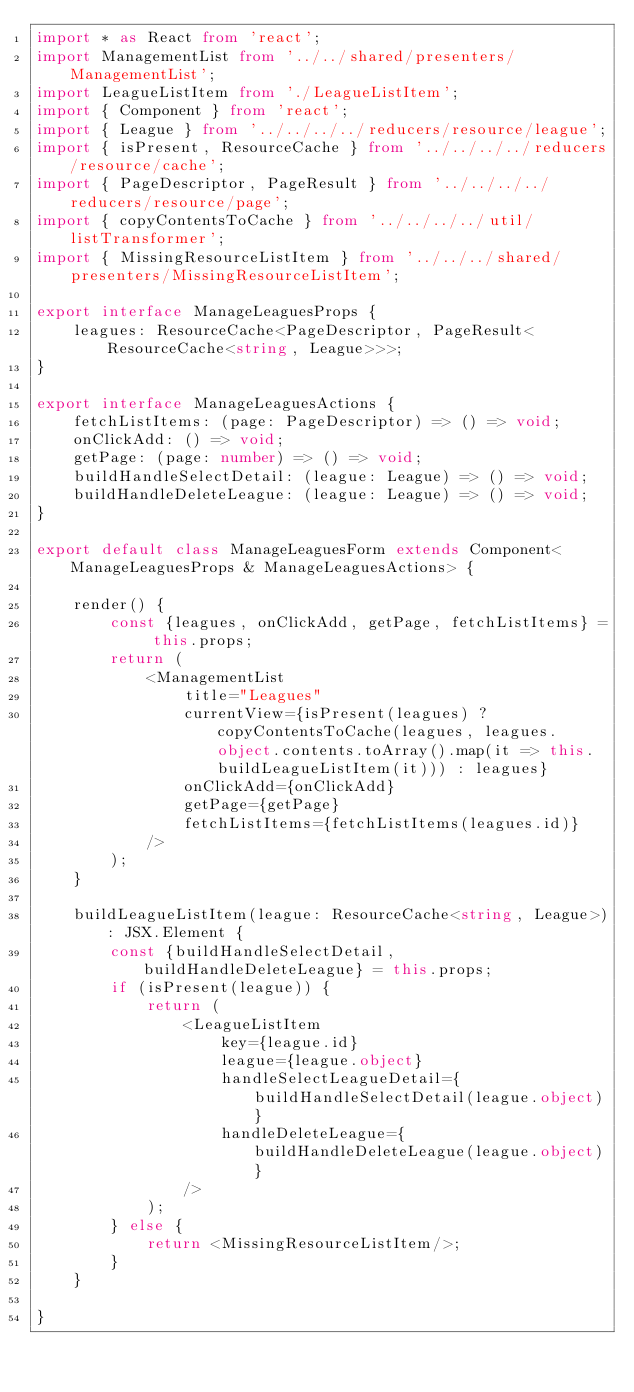Convert code to text. <code><loc_0><loc_0><loc_500><loc_500><_TypeScript_>import * as React from 'react';
import ManagementList from '../../shared/presenters/ManagementList';
import LeagueListItem from './LeagueListItem';
import { Component } from 'react';
import { League } from '../../../../reducers/resource/league';
import { isPresent, ResourceCache } from '../../../../reducers/resource/cache';
import { PageDescriptor, PageResult } from '../../../../reducers/resource/page';
import { copyContentsToCache } from '../../../../util/listTransformer';
import { MissingResourceListItem } from '../../../shared/presenters/MissingResourceListItem';

export interface ManageLeaguesProps {
    leagues: ResourceCache<PageDescriptor, PageResult<ResourceCache<string, League>>>;
}

export interface ManageLeaguesActions {
    fetchListItems: (page: PageDescriptor) => () => void;
    onClickAdd: () => void;
    getPage: (page: number) => () => void;
    buildHandleSelectDetail: (league: League) => () => void;
    buildHandleDeleteLeague: (league: League) => () => void;
}

export default class ManageLeaguesForm extends Component<ManageLeaguesProps & ManageLeaguesActions> {

    render() {
        const {leagues, onClickAdd, getPage, fetchListItems} = this.props;
        return (
            <ManagementList
                title="Leagues"
                currentView={isPresent(leagues) ? copyContentsToCache(leagues, leagues.object.contents.toArray().map(it => this.buildLeagueListItem(it))) : leagues}
                onClickAdd={onClickAdd}
                getPage={getPage}
                fetchListItems={fetchListItems(leagues.id)}
            />
        );
    }

    buildLeagueListItem(league: ResourceCache<string, League>): JSX.Element {
        const {buildHandleSelectDetail, buildHandleDeleteLeague} = this.props;
        if (isPresent(league)) {
            return (
                <LeagueListItem
                    key={league.id}
                    league={league.object}
                    handleSelectLeagueDetail={buildHandleSelectDetail(league.object)}
                    handleDeleteLeague={buildHandleDeleteLeague(league.object)}
                />
            );
        } else {
            return <MissingResourceListItem/>;
        }
    }

}</code> 